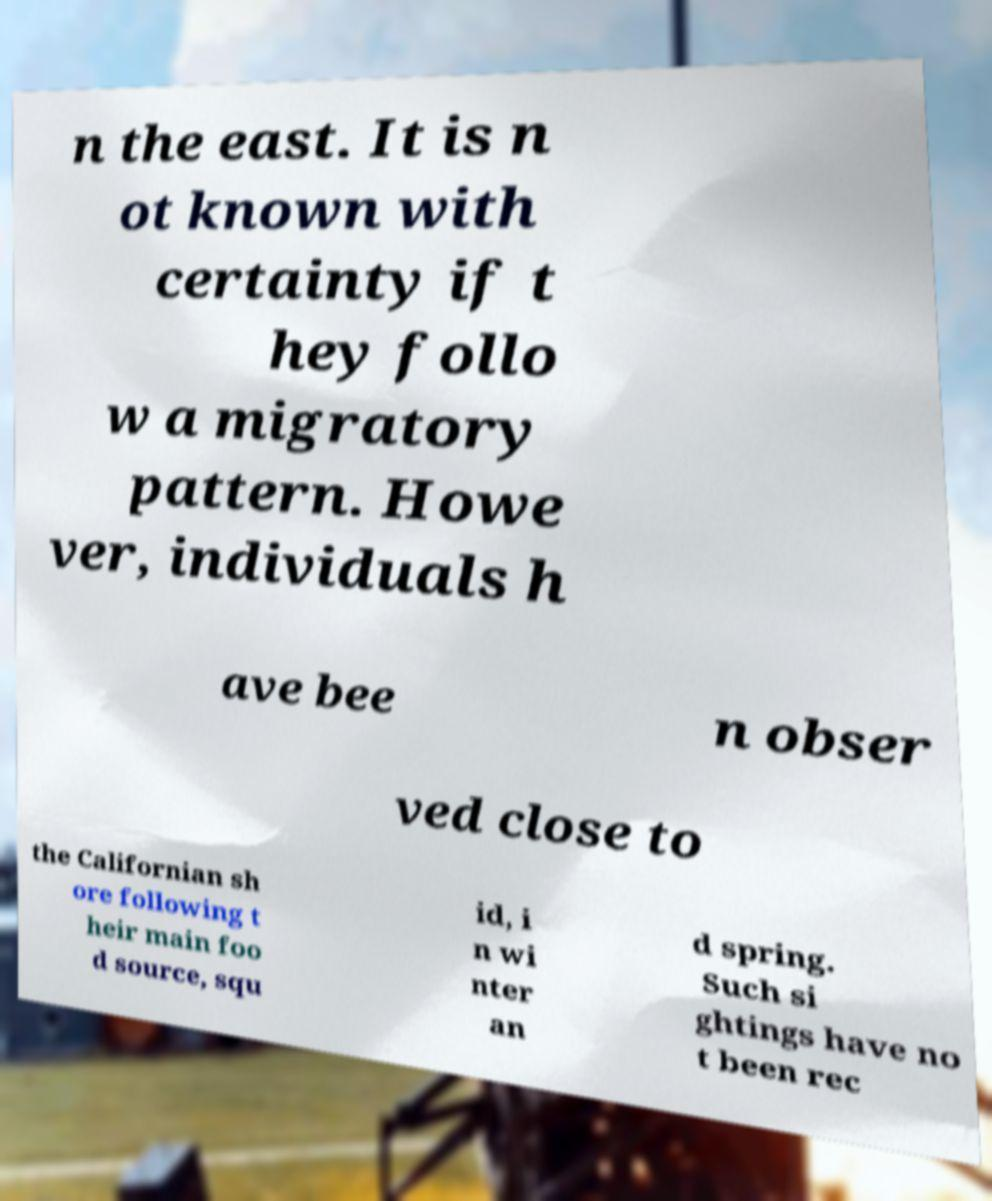What messages or text are displayed in this image? I need them in a readable, typed format. n the east. It is n ot known with certainty if t hey follo w a migratory pattern. Howe ver, individuals h ave bee n obser ved close to the Californian sh ore following t heir main foo d source, squ id, i n wi nter an d spring. Such si ghtings have no t been rec 